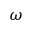Convert formula to latex. <formula><loc_0><loc_0><loc_500><loc_500>\omega</formula> 